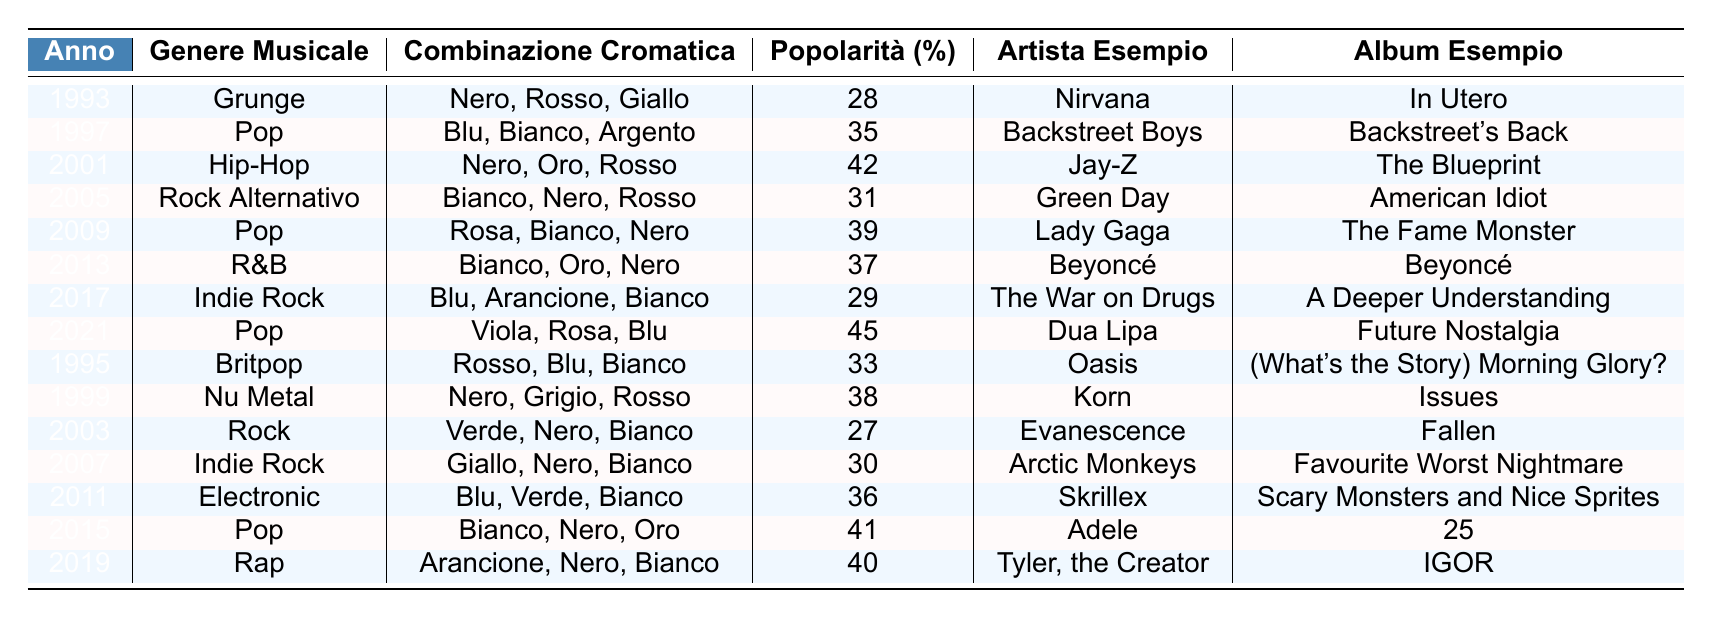Qual è la combinazione cromatica più popolare nel 2021? Nel 2021, la combinazione cromatica è "Viola, Rosa, Blu" con una popolarità del 45%.
Answer: Viola, Rosa, Blu Quale genere musicale ha la combinazione cromatica "Nero, Oro, Rosso"? La combinazione cromatica "Nero, Oro, Rosso" è associata al genere musicale Hip-Hop nel 2001.
Answer: Hip-Hop Qual è stata la popolarità media delle combinazioni cromatiche nelle copertine pop? Le popolarità per il pop sono 35% (1997), 39% (2009), 45% (2021) e 41% (2015). La media è (35 + 39 + 45 + 41) / 4 = 40%
Answer: 40% Quale artista ha utilizzato la combinazione "Giallo, Nero, Bianco" e in quale anno? L'artista Arctic Monkeys ha utilizzato la combinazione "Giallo, Nero, Bianco" nel 2007.
Answer: Arctic Monkeys, 2007 Esiste un album del 2009 che utilizza "Nero, Bianco, Rosa"? Sì, l'album "The Fame Monster" di Lady Gaga utilizza la combinazione "Nero, Bianco, Rosa" nel 2009.
Answer: Sì Quale genere musicale mostrava la combinazione "Blu, Verde, Bianco"? La combinazione "Blu, Verde, Bianco" è associata al genere musicale Electronic nel 2011.
Answer: Electronic Qual è la combinazione cromatica più popolare fra gli album pubblicati nel 1993 e nel 1995? Confrontando il 1993 (28%) e il 1995 (33%), la combinazione cromatica più popolare è "Rosso, Blu, Bianco" del 1995.
Answer: Rosso, Blu, Bianco Quando è stata utilizzata per la prima volta la combinazione "Nero, Grigio, Rosso"? La combinazione "Nero, Grigio, Rosso" è stata utilizzata nel genere Nu Metal nel 1999.
Answer: 1999 Quale combinazione cromatica ha la popolarità più bassa nel table? La combinazione con la popolarità più bassa è "Verde, Nero, Bianco" con il 27% nel 2003.
Answer: Verde, Nero, Bianco Quante combinazioni cromatiche includono il colore "Nero"? Le combinazioni cromatiche che includono "Nero" sono: "Nero, Rosso, Giallo" (1993), "Nero, Oro, Rosso" (2001), "Nero, Bianco, Rosa" (2009), "Bianco, Oro, Nero" (2013), "Nero, Grigio, Rosso" (1999), "Nero, Bianco, Arancione" (2017). Ci sono 6 combinazioni.
Answer: 6 